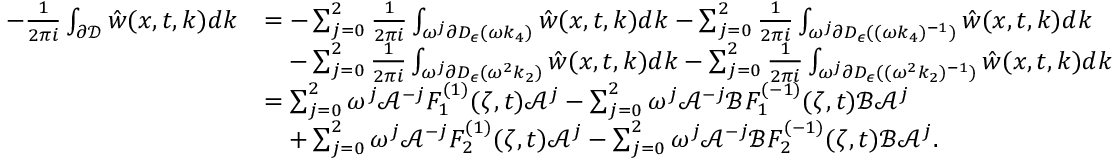<formula> <loc_0><loc_0><loc_500><loc_500>\begin{array} { r l } { - \frac { 1 } { 2 \pi i } \int _ { \partial \mathcal { D } } \hat { w } ( x , t , k ) d k } & { = - \sum _ { j = 0 } ^ { 2 } \frac { 1 } { 2 \pi i } \int _ { \omega ^ { j } \partial D _ { \epsilon } ( \omega k _ { 4 } ) } \hat { w } ( x , t , k ) d k - \sum _ { j = 0 } ^ { 2 } \frac { 1 } { 2 \pi i } \int _ { \omega ^ { j } \partial D _ { \epsilon } ( ( \omega k _ { 4 } ) ^ { - 1 } ) } \hat { w } ( x , t , k ) d k } \\ & { \quad - \sum _ { j = 0 } ^ { 2 } \frac { 1 } { 2 \pi i } \int _ { \omega ^ { j } \partial D _ { \epsilon } ( \omega ^ { 2 } k _ { 2 } ) } \hat { w } ( x , t , k ) d k - \sum _ { j = 0 } ^ { 2 } \frac { 1 } { 2 \pi i } \int _ { \omega ^ { j } \partial D _ { \epsilon } ( ( \omega ^ { 2 } k _ { 2 } ) ^ { - 1 } ) } \hat { w } ( x , t , k ) d k } \\ & { = \sum _ { j = 0 } ^ { 2 } \omega ^ { j } \mathcal { A } ^ { - j } F _ { 1 } ^ { ( 1 ) } ( \zeta , t ) \mathcal { A } ^ { j } - \sum _ { j = 0 } ^ { 2 } \omega ^ { j } \mathcal { A } ^ { - j } \mathcal { B } F _ { 1 } ^ { ( - 1 ) } ( \zeta , t ) \mathcal { B } \mathcal { A } ^ { j } } \\ & { \quad + \sum _ { j = 0 } ^ { 2 } \omega ^ { j } \mathcal { A } ^ { - j } F _ { 2 } ^ { ( 1 ) } ( \zeta , t ) \mathcal { A } ^ { j } - \sum _ { j = 0 } ^ { 2 } \omega ^ { j } \mathcal { A } ^ { - j } \mathcal { B } F _ { 2 } ^ { ( - 1 ) } ( \zeta , t ) \mathcal { B } \mathcal { A } ^ { j } . } \end{array}</formula> 